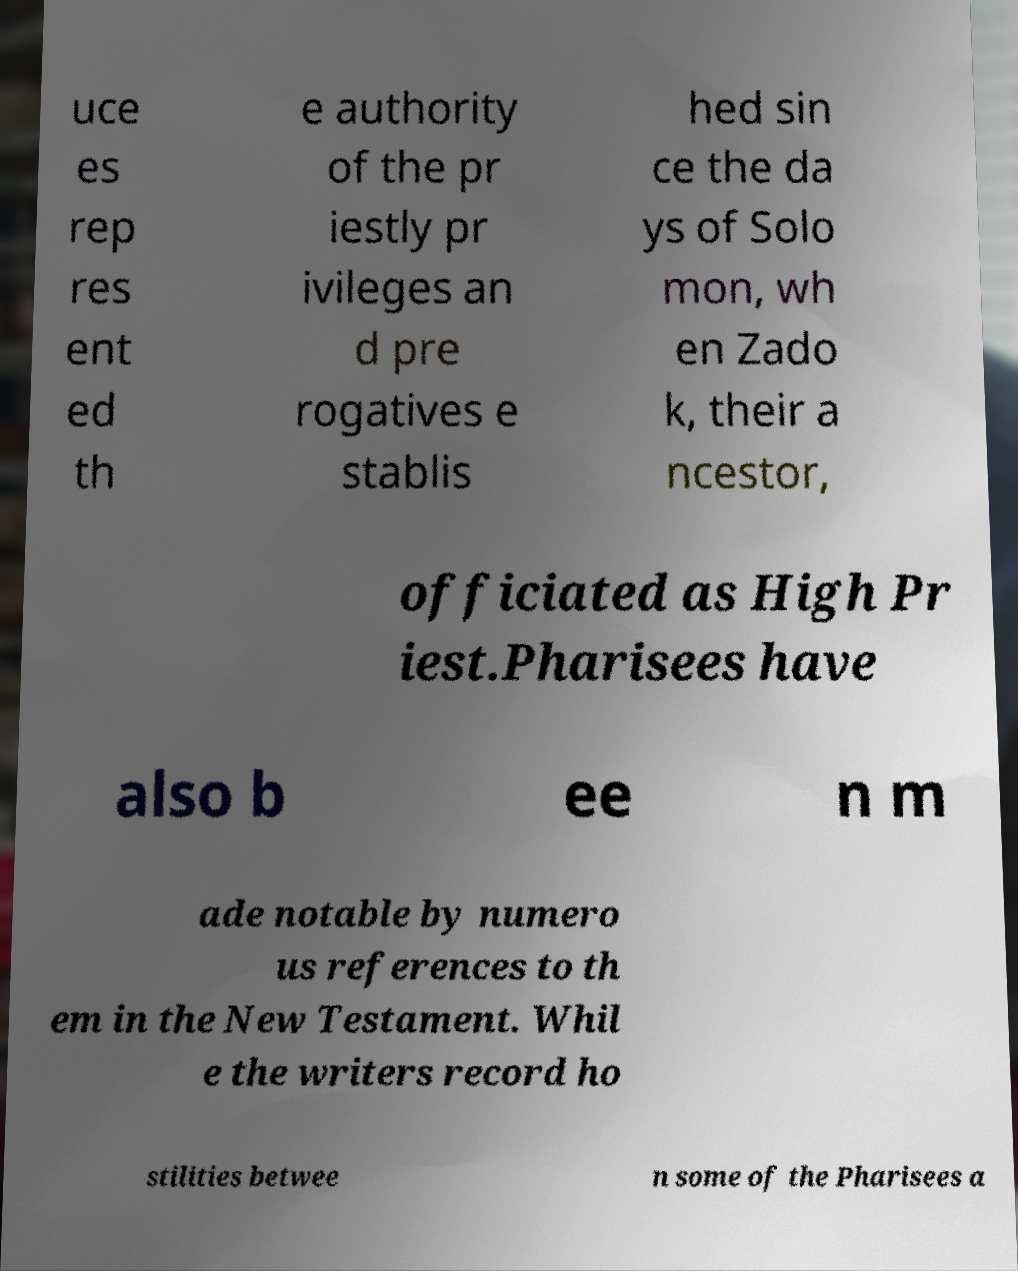What messages or text are displayed in this image? I need them in a readable, typed format. uce es rep res ent ed th e authority of the pr iestly pr ivileges an d pre rogatives e stablis hed sin ce the da ys of Solo mon, wh en Zado k, their a ncestor, officiated as High Pr iest.Pharisees have also b ee n m ade notable by numero us references to th em in the New Testament. Whil e the writers record ho stilities betwee n some of the Pharisees a 